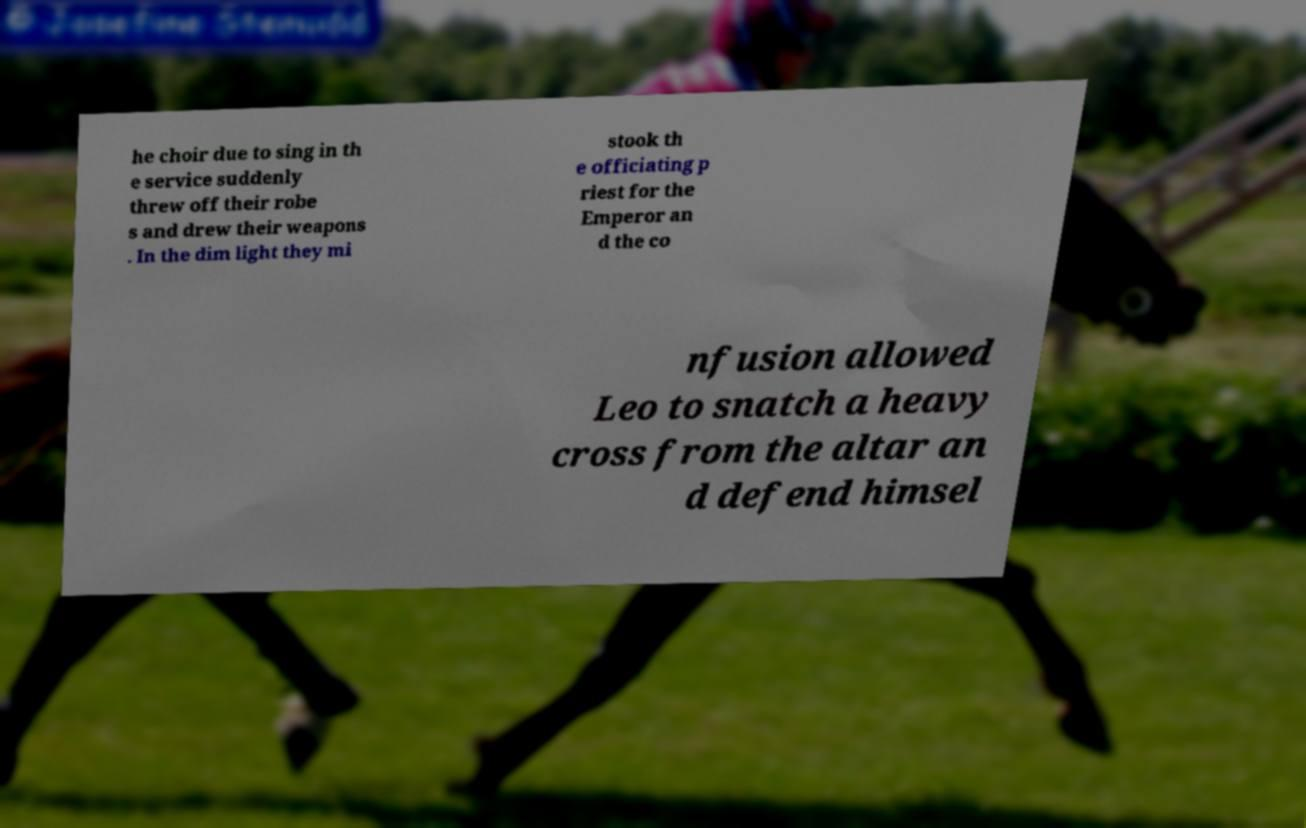There's text embedded in this image that I need extracted. Can you transcribe it verbatim? he choir due to sing in th e service suddenly threw off their robe s and drew their weapons . In the dim light they mi stook th e officiating p riest for the Emperor an d the co nfusion allowed Leo to snatch a heavy cross from the altar an d defend himsel 